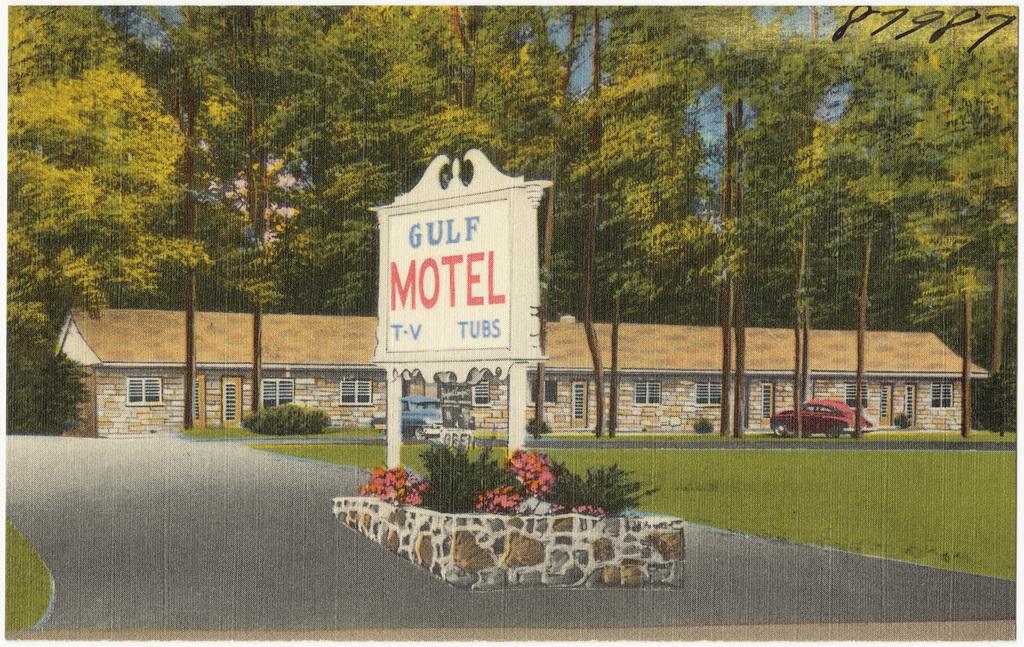Could you give a brief overview of what you see in this image? It is a poster. In this image, we can see a house with walls, doors, glass windows. Here there are few vehicles, plants, grass and walkway. In the middle of the image, we can see a name board with pillars. Background there are so many trees. Right side top corner, we can see some numerical numbers. 